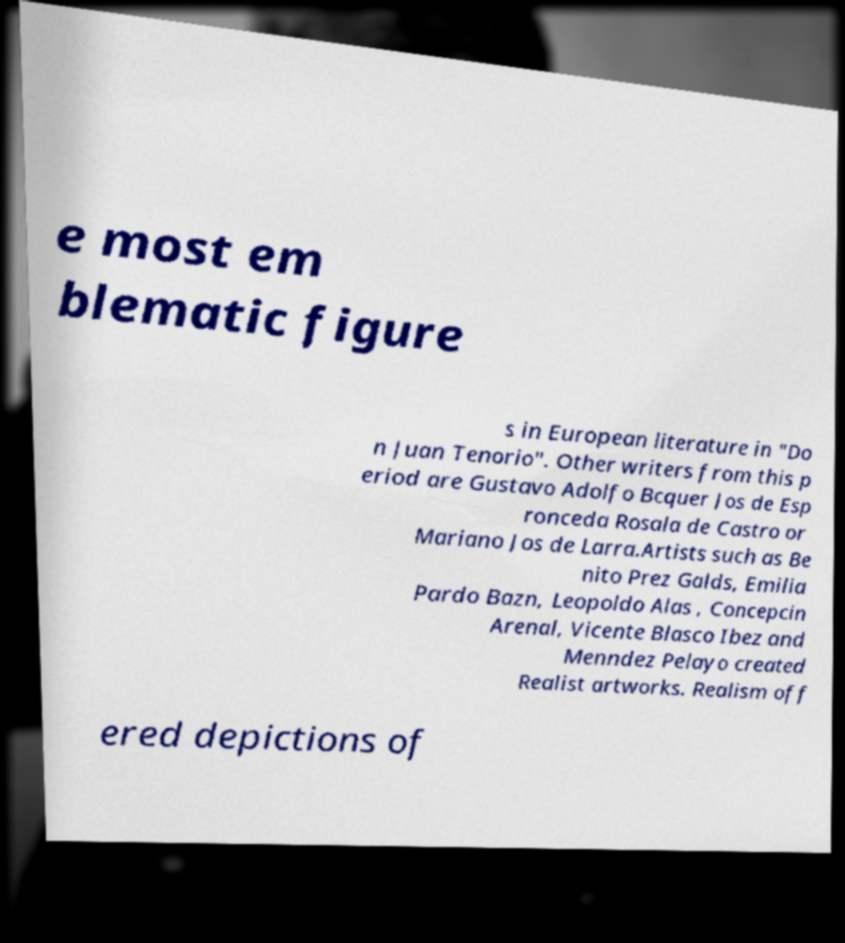For documentation purposes, I need the text within this image transcribed. Could you provide that? e most em blematic figure s in European literature in "Do n Juan Tenorio". Other writers from this p eriod are Gustavo Adolfo Bcquer Jos de Esp ronceda Rosala de Castro or Mariano Jos de Larra.Artists such as Be nito Prez Galds, Emilia Pardo Bazn, Leopoldo Alas , Concepcin Arenal, Vicente Blasco Ibez and Menndez Pelayo created Realist artworks. Realism off ered depictions of 